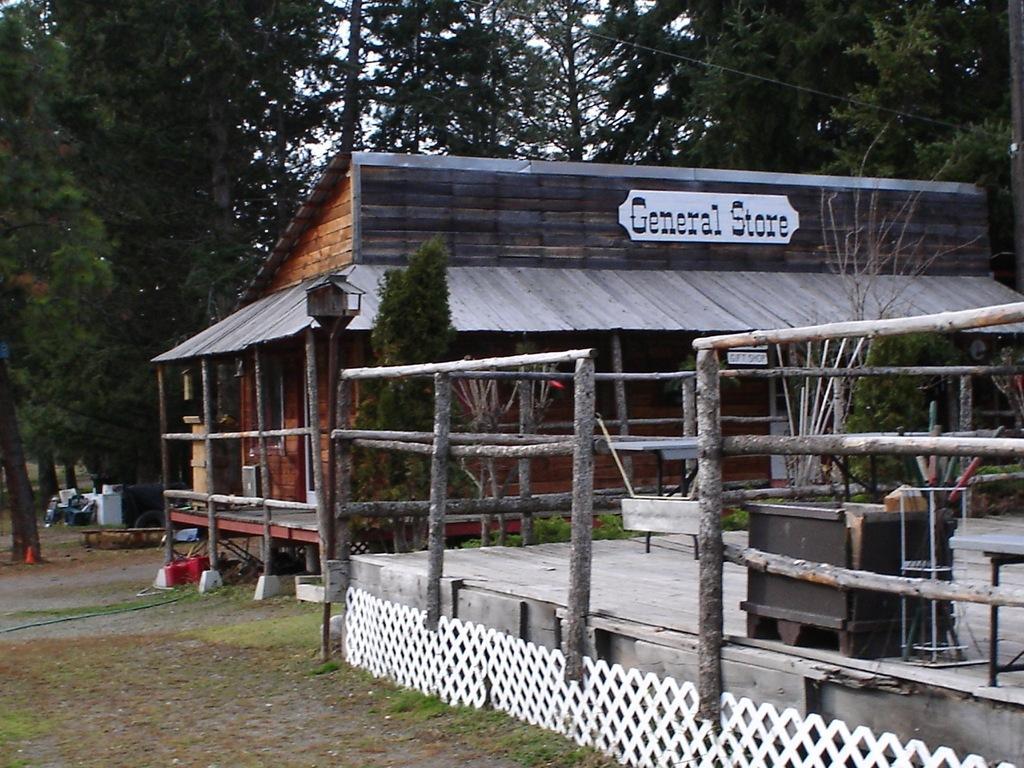Please provide a concise description of this image. In this image I see a house over here and I see a board on which there are words written and I see the wooden fencing and I see the grass and I see plants. In the background I see the plants and the sky. 